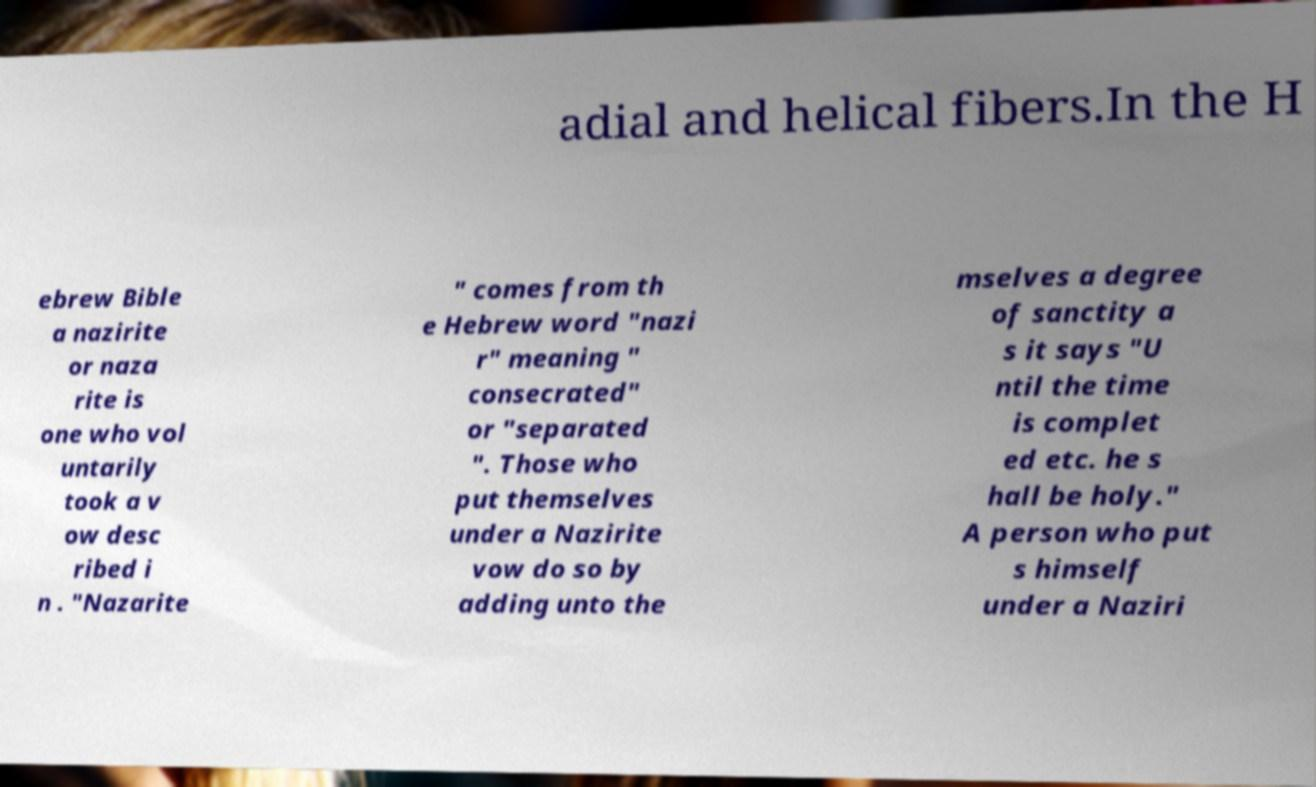I need the written content from this picture converted into text. Can you do that? adial and helical fibers.In the H ebrew Bible a nazirite or naza rite is one who vol untarily took a v ow desc ribed i n . "Nazarite " comes from th e Hebrew word "nazi r" meaning " consecrated" or "separated ". Those who put themselves under a Nazirite vow do so by adding unto the mselves a degree of sanctity a s it says "U ntil the time is complet ed etc. he s hall be holy." A person who put s himself under a Naziri 